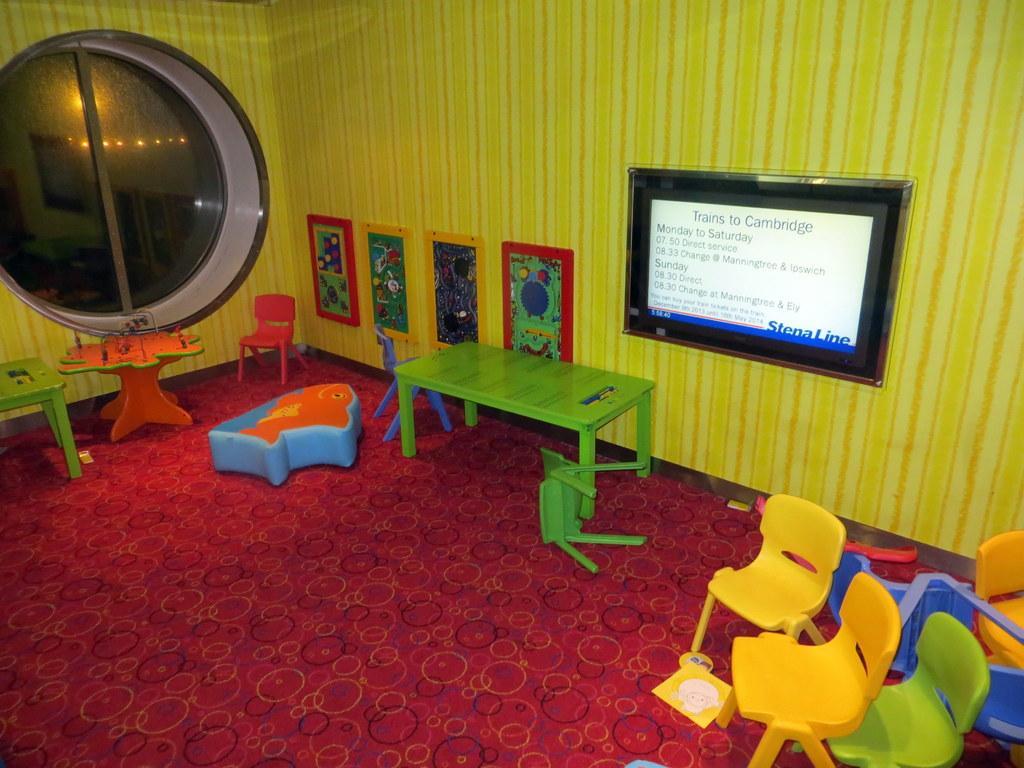How would you summarize this image in a sentence or two? The image is inside the room. In the image on right side we can see chairs, on left side there is a table,chair and a glass door. In middle there is a wall,screen and few photo frames at bottom there is a red color mat. 